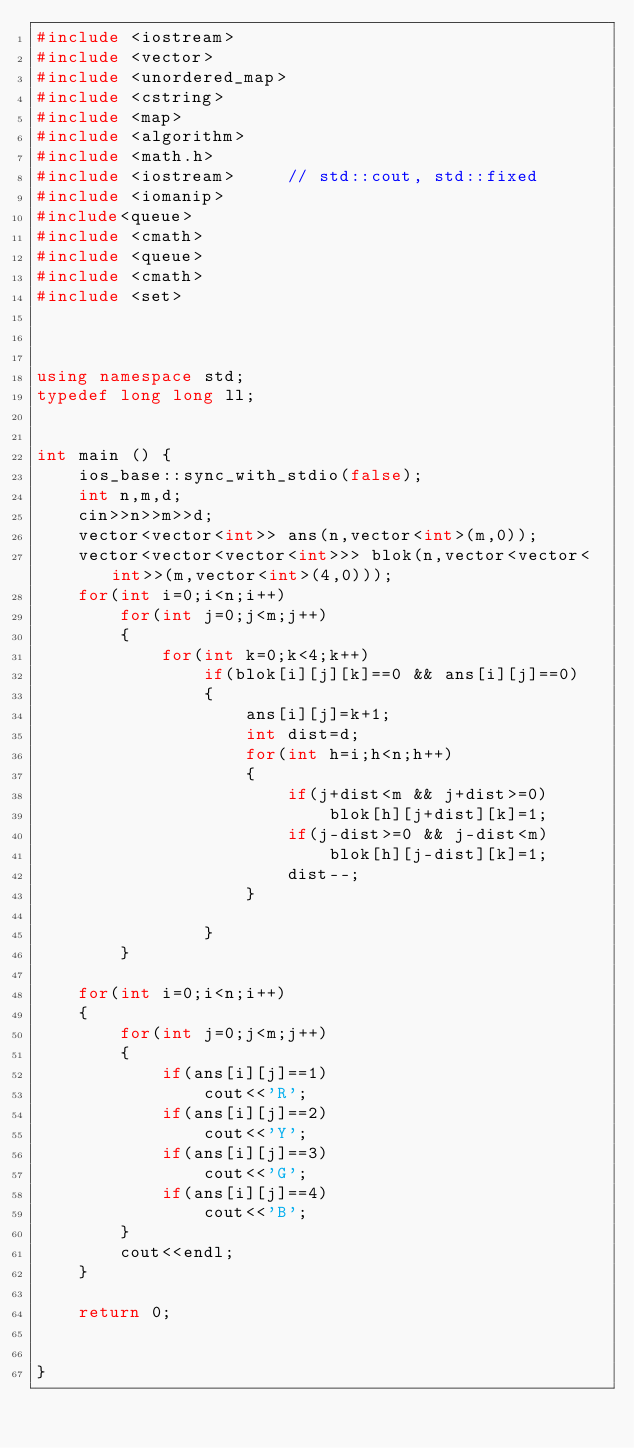<code> <loc_0><loc_0><loc_500><loc_500><_C++_>#include <iostream>
#include <vector>
#include <unordered_map>
#include <cstring>
#include <map>
#include <algorithm>
#include <math.h>
#include <iostream>     // std::cout, std::fixed
#include <iomanip>
#include<queue>
#include <cmath>
#include <queue>
#include <cmath>
#include <set>



using namespace std;
typedef long long ll;


int main () {
    ios_base::sync_with_stdio(false);
    int n,m,d;
    cin>>n>>m>>d;
    vector<vector<int>> ans(n,vector<int>(m,0));
    vector<vector<vector<int>>> blok(n,vector<vector<int>>(m,vector<int>(4,0)));
    for(int i=0;i<n;i++)
        for(int j=0;j<m;j++)
        {
            for(int k=0;k<4;k++)
                if(blok[i][j][k]==0 && ans[i][j]==0)
                {
                    ans[i][j]=k+1;
                    int dist=d;
                    for(int h=i;h<n;h++)
                    {
                        if(j+dist<m && j+dist>=0)
                            blok[h][j+dist][k]=1;
                        if(j-dist>=0 && j-dist<m)
                            blok[h][j-dist][k]=1;
                        dist--;
                    }
                        
                }
        }
    
    for(int i=0;i<n;i++)
    {
        for(int j=0;j<m;j++)
        {
            if(ans[i][j]==1)
                cout<<'R';
            if(ans[i][j]==2)
                cout<<'Y';
            if(ans[i][j]==3)
                cout<<'G';
            if(ans[i][j]==4)
                cout<<'B';
        }
        cout<<endl;
    }

    return 0;

    
}
</code> 